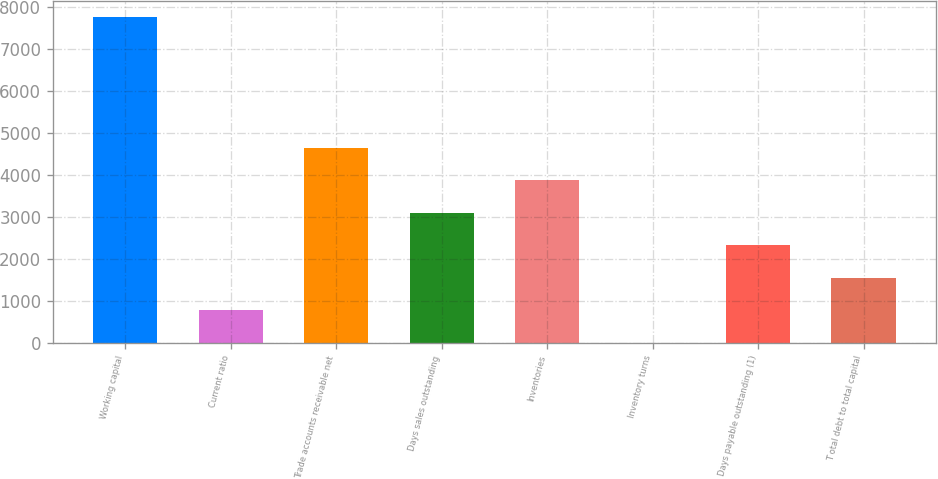<chart> <loc_0><loc_0><loc_500><loc_500><bar_chart><fcel>Working capital<fcel>Current ratio<fcel>Trade accounts receivable net<fcel>Days sales outstanding<fcel>Inventories<fcel>Inventory turns<fcel>Days payable outstanding (1)<fcel>T otal debt to total capital<nl><fcel>7739<fcel>778.04<fcel>4645.24<fcel>3098.36<fcel>3871.8<fcel>4.6<fcel>2324.92<fcel>1551.48<nl></chart> 